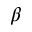<formula> <loc_0><loc_0><loc_500><loc_500>\beta</formula> 